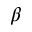<formula> <loc_0><loc_0><loc_500><loc_500>\beta</formula> 